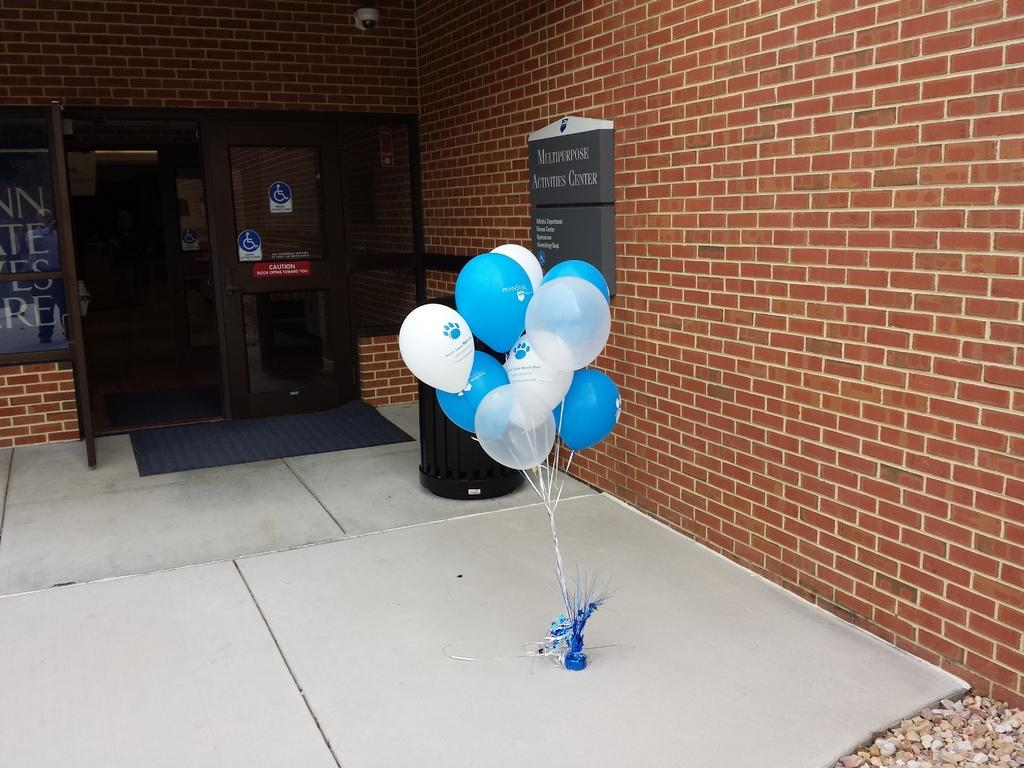What objects are present in the image? There are balloons in the image. What type of structure can be seen in the image? There is a door in the image. What is the color of the door? The door is in brown color. What town is the queen visiting in the image? There is no town or queen present in the image; it only features balloons and a brown door. 